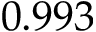Convert formula to latex. <formula><loc_0><loc_0><loc_500><loc_500>0 . 9 9 3</formula> 